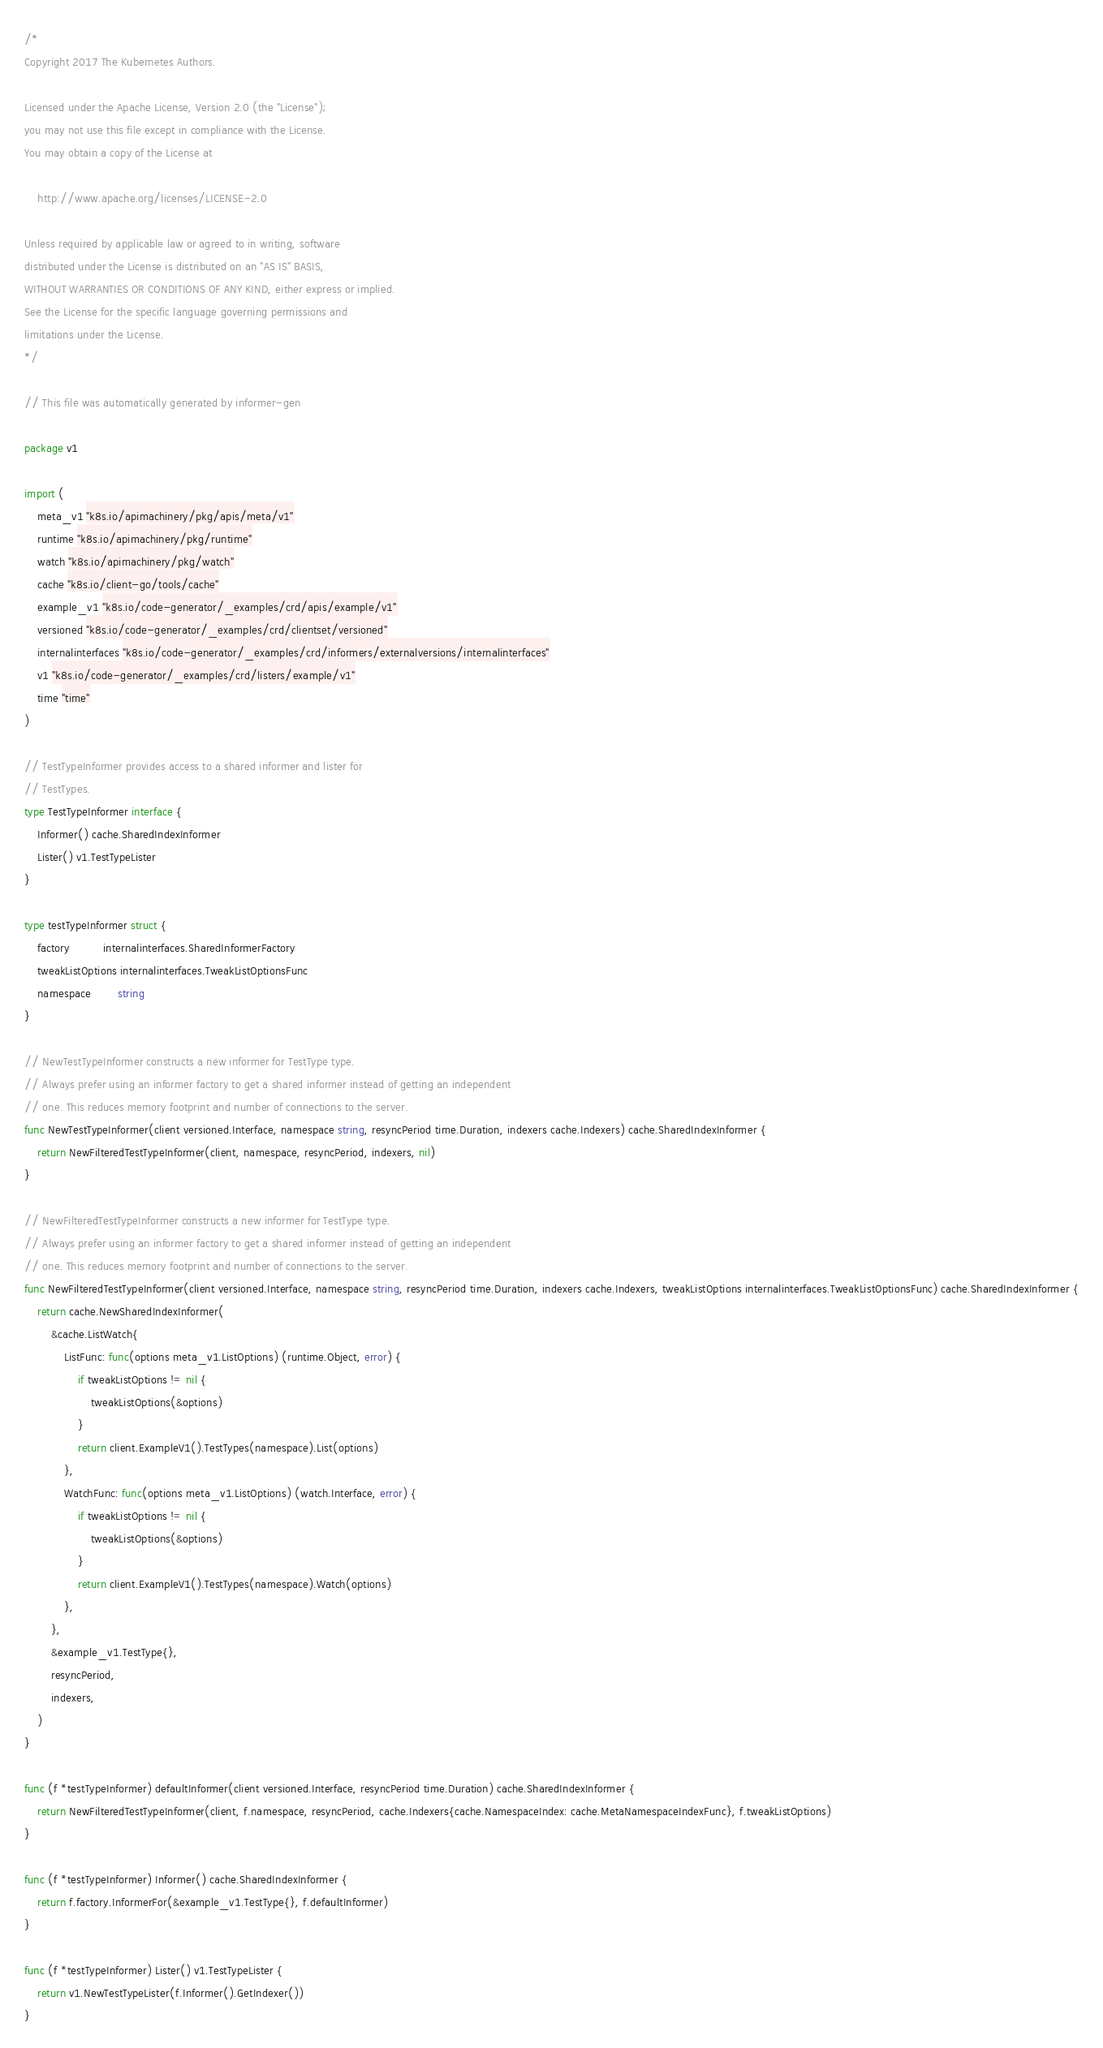<code> <loc_0><loc_0><loc_500><loc_500><_Go_>/*
Copyright 2017 The Kubernetes Authors.

Licensed under the Apache License, Version 2.0 (the "License");
you may not use this file except in compliance with the License.
You may obtain a copy of the License at

    http://www.apache.org/licenses/LICENSE-2.0

Unless required by applicable law or agreed to in writing, software
distributed under the License is distributed on an "AS IS" BASIS,
WITHOUT WARRANTIES OR CONDITIONS OF ANY KIND, either express or implied.
See the License for the specific language governing permissions and
limitations under the License.
*/

// This file was automatically generated by informer-gen

package v1

import (
	meta_v1 "k8s.io/apimachinery/pkg/apis/meta/v1"
	runtime "k8s.io/apimachinery/pkg/runtime"
	watch "k8s.io/apimachinery/pkg/watch"
	cache "k8s.io/client-go/tools/cache"
	example_v1 "k8s.io/code-generator/_examples/crd/apis/example/v1"
	versioned "k8s.io/code-generator/_examples/crd/clientset/versioned"
	internalinterfaces "k8s.io/code-generator/_examples/crd/informers/externalversions/internalinterfaces"
	v1 "k8s.io/code-generator/_examples/crd/listers/example/v1"
	time "time"
)

// TestTypeInformer provides access to a shared informer and lister for
// TestTypes.
type TestTypeInformer interface {
	Informer() cache.SharedIndexInformer
	Lister() v1.TestTypeLister
}

type testTypeInformer struct {
	factory          internalinterfaces.SharedInformerFactory
	tweakListOptions internalinterfaces.TweakListOptionsFunc
	namespace        string
}

// NewTestTypeInformer constructs a new informer for TestType type.
// Always prefer using an informer factory to get a shared informer instead of getting an independent
// one. This reduces memory footprint and number of connections to the server.
func NewTestTypeInformer(client versioned.Interface, namespace string, resyncPeriod time.Duration, indexers cache.Indexers) cache.SharedIndexInformer {
	return NewFilteredTestTypeInformer(client, namespace, resyncPeriod, indexers, nil)
}

// NewFilteredTestTypeInformer constructs a new informer for TestType type.
// Always prefer using an informer factory to get a shared informer instead of getting an independent
// one. This reduces memory footprint and number of connections to the server.
func NewFilteredTestTypeInformer(client versioned.Interface, namespace string, resyncPeriod time.Duration, indexers cache.Indexers, tweakListOptions internalinterfaces.TweakListOptionsFunc) cache.SharedIndexInformer {
	return cache.NewSharedIndexInformer(
		&cache.ListWatch{
			ListFunc: func(options meta_v1.ListOptions) (runtime.Object, error) {
				if tweakListOptions != nil {
					tweakListOptions(&options)
				}
				return client.ExampleV1().TestTypes(namespace).List(options)
			},
			WatchFunc: func(options meta_v1.ListOptions) (watch.Interface, error) {
				if tweakListOptions != nil {
					tweakListOptions(&options)
				}
				return client.ExampleV1().TestTypes(namespace).Watch(options)
			},
		},
		&example_v1.TestType{},
		resyncPeriod,
		indexers,
	)
}

func (f *testTypeInformer) defaultInformer(client versioned.Interface, resyncPeriod time.Duration) cache.SharedIndexInformer {
	return NewFilteredTestTypeInformer(client, f.namespace, resyncPeriod, cache.Indexers{cache.NamespaceIndex: cache.MetaNamespaceIndexFunc}, f.tweakListOptions)
}

func (f *testTypeInformer) Informer() cache.SharedIndexInformer {
	return f.factory.InformerFor(&example_v1.TestType{}, f.defaultInformer)
}

func (f *testTypeInformer) Lister() v1.TestTypeLister {
	return v1.NewTestTypeLister(f.Informer().GetIndexer())
}
</code> 